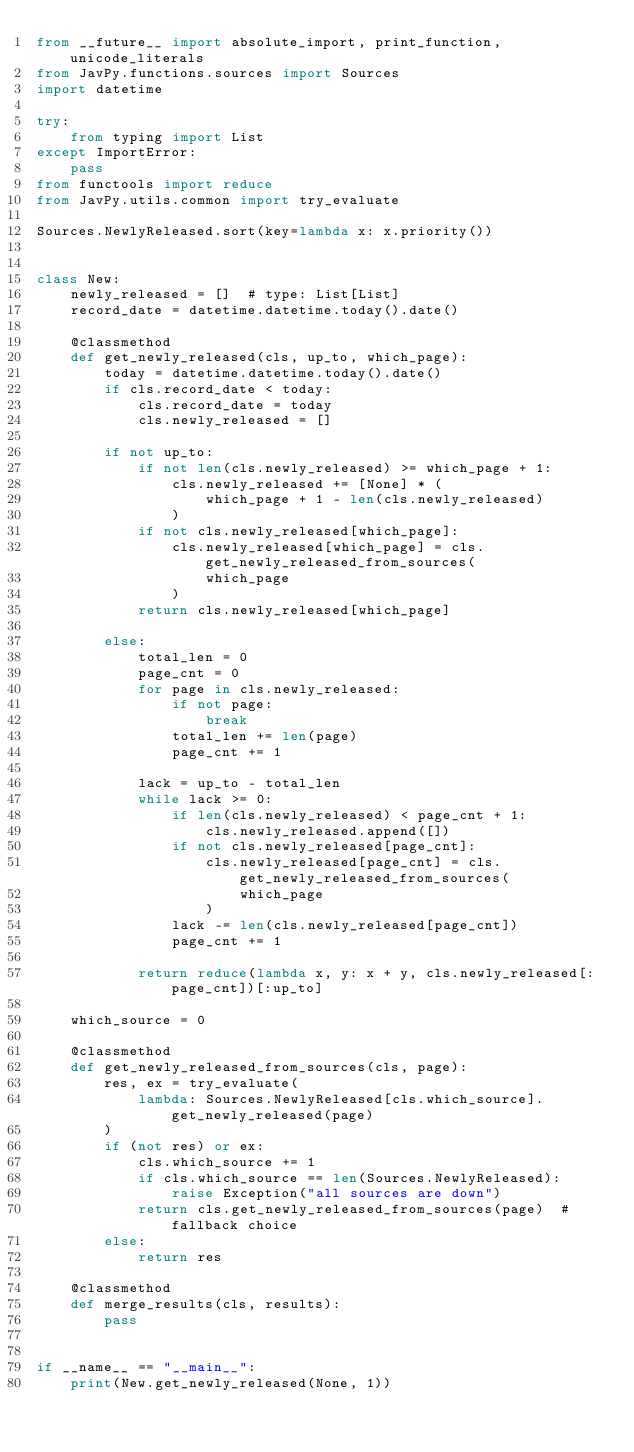<code> <loc_0><loc_0><loc_500><loc_500><_Python_>from __future__ import absolute_import, print_function, unicode_literals
from JavPy.functions.sources import Sources
import datetime

try:
    from typing import List
except ImportError:
    pass
from functools import reduce
from JavPy.utils.common import try_evaluate

Sources.NewlyReleased.sort(key=lambda x: x.priority())


class New:
    newly_released = []  # type: List[List]
    record_date = datetime.datetime.today().date()

    @classmethod
    def get_newly_released(cls, up_to, which_page):
        today = datetime.datetime.today().date()
        if cls.record_date < today:
            cls.record_date = today
            cls.newly_released = []

        if not up_to:
            if not len(cls.newly_released) >= which_page + 1:
                cls.newly_released += [None] * (
                    which_page + 1 - len(cls.newly_released)
                )
            if not cls.newly_released[which_page]:
                cls.newly_released[which_page] = cls.get_newly_released_from_sources(
                    which_page
                )
            return cls.newly_released[which_page]

        else:
            total_len = 0
            page_cnt = 0
            for page in cls.newly_released:
                if not page:
                    break
                total_len += len(page)
                page_cnt += 1

            lack = up_to - total_len
            while lack >= 0:
                if len(cls.newly_released) < page_cnt + 1:
                    cls.newly_released.append([])
                if not cls.newly_released[page_cnt]:
                    cls.newly_released[page_cnt] = cls.get_newly_released_from_sources(
                        which_page
                    )
                lack -= len(cls.newly_released[page_cnt])
                page_cnt += 1

            return reduce(lambda x, y: x + y, cls.newly_released[:page_cnt])[:up_to]

    which_source = 0

    @classmethod
    def get_newly_released_from_sources(cls, page):
        res, ex = try_evaluate(
            lambda: Sources.NewlyReleased[cls.which_source].get_newly_released(page)
        )
        if (not res) or ex:
            cls.which_source += 1
            if cls.which_source == len(Sources.NewlyReleased):
                raise Exception("all sources are down")
            return cls.get_newly_released_from_sources(page)  # fallback choice
        else:
            return res

    @classmethod
    def merge_results(cls, results):
        pass


if __name__ == "__main__":
    print(New.get_newly_released(None, 1))
</code> 